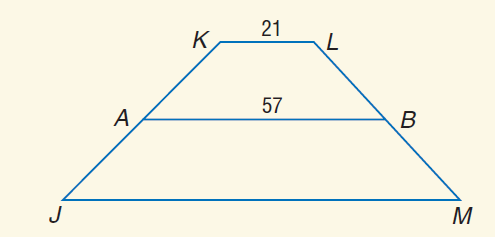Question: For trapezoid J K L M, A and B are midpoints of the legs. If A B = 57 and K L = 21, find J M.
Choices:
A. 21
B. 57
C. 87
D. 93
Answer with the letter. Answer: D 